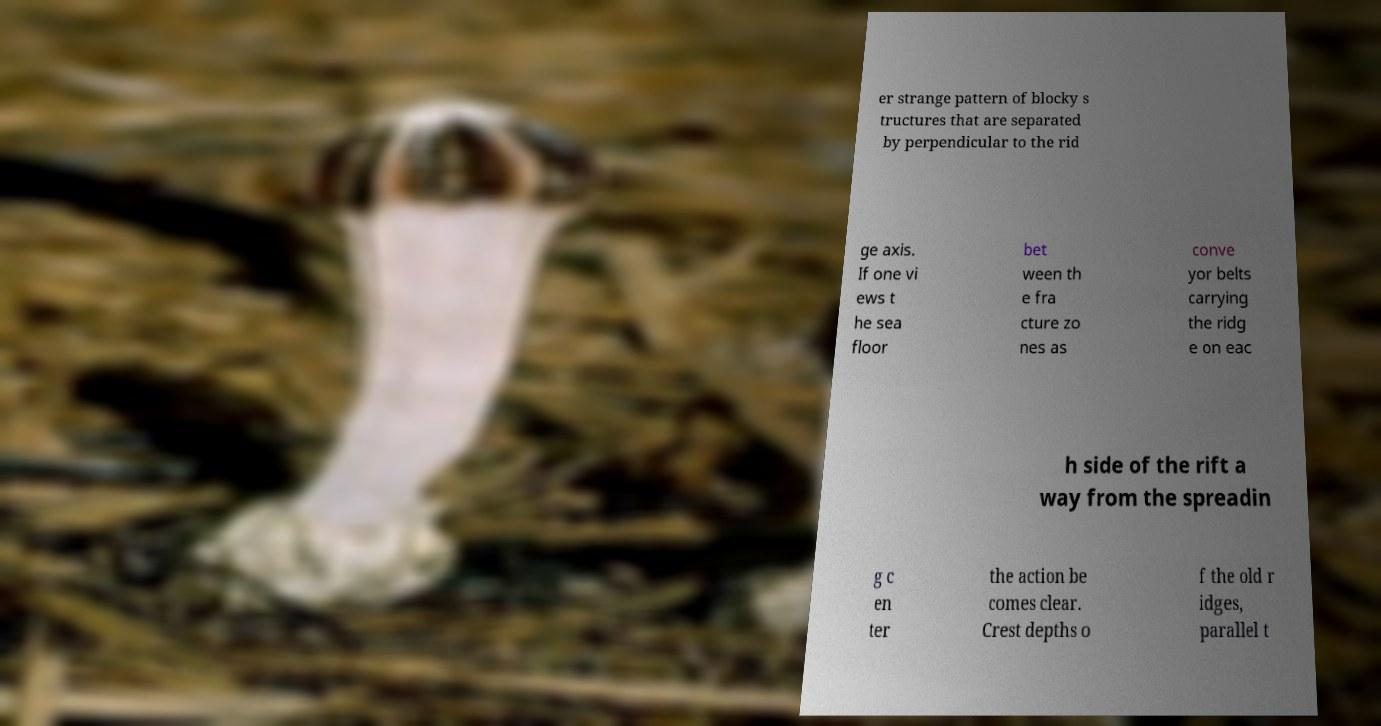What messages or text are displayed in this image? I need them in a readable, typed format. er strange pattern of blocky s tructures that are separated by perpendicular to the rid ge axis. If one vi ews t he sea floor bet ween th e fra cture zo nes as conve yor belts carrying the ridg e on eac h side of the rift a way from the spreadin g c en ter the action be comes clear. Crest depths o f the old r idges, parallel t 